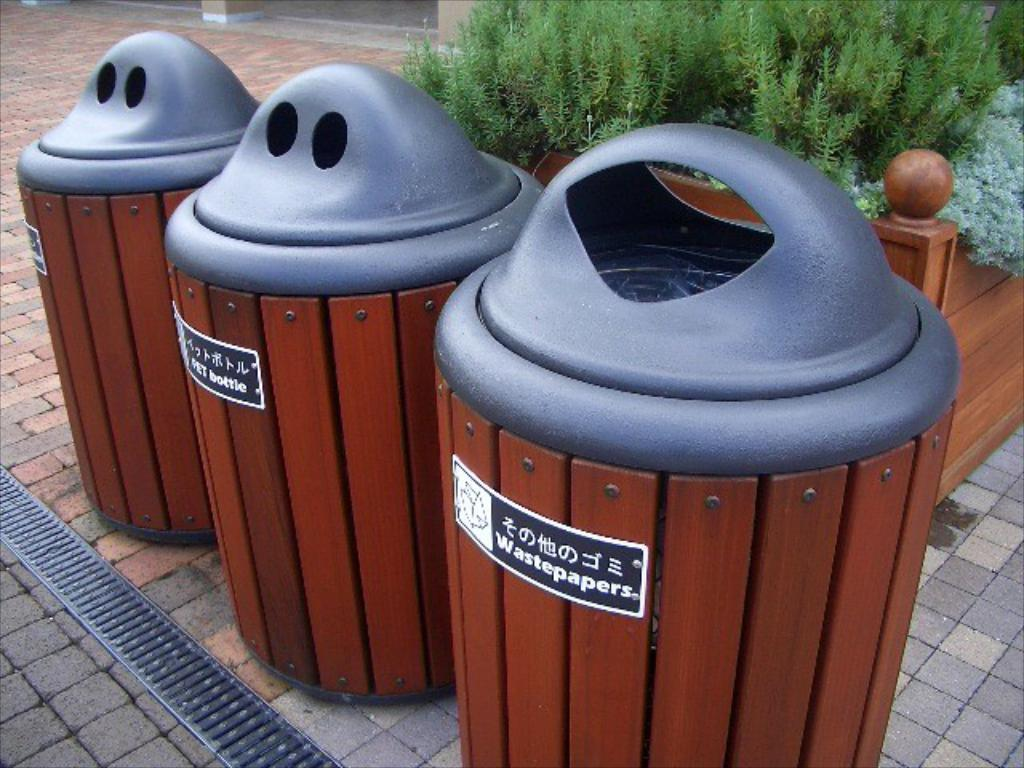<image>
Provide a brief description of the given image. three trashcans sit next to each other with one being labeled "wastepaper" 